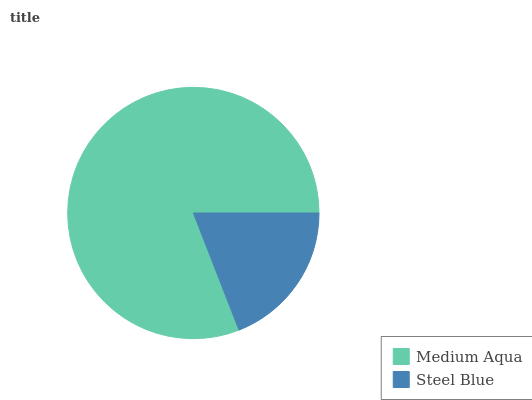Is Steel Blue the minimum?
Answer yes or no. Yes. Is Medium Aqua the maximum?
Answer yes or no. Yes. Is Steel Blue the maximum?
Answer yes or no. No. Is Medium Aqua greater than Steel Blue?
Answer yes or no. Yes. Is Steel Blue less than Medium Aqua?
Answer yes or no. Yes. Is Steel Blue greater than Medium Aqua?
Answer yes or no. No. Is Medium Aqua less than Steel Blue?
Answer yes or no. No. Is Medium Aqua the high median?
Answer yes or no. Yes. Is Steel Blue the low median?
Answer yes or no. Yes. Is Steel Blue the high median?
Answer yes or no. No. Is Medium Aqua the low median?
Answer yes or no. No. 